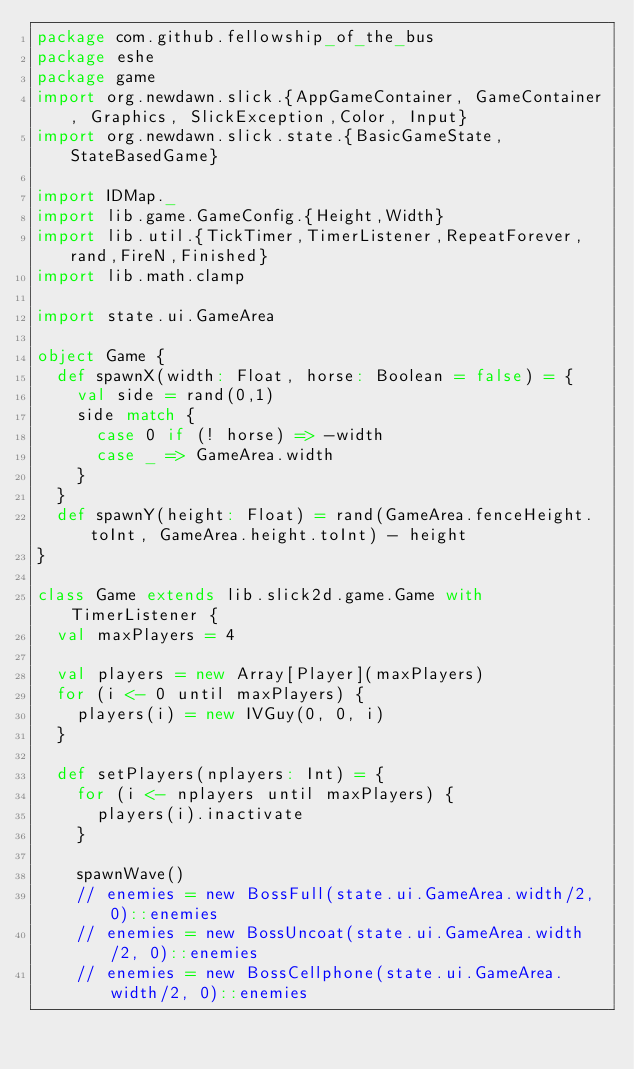<code> <loc_0><loc_0><loc_500><loc_500><_Scala_>package com.github.fellowship_of_the_bus
package eshe
package game
import org.newdawn.slick.{AppGameContainer, GameContainer, Graphics, SlickException,Color, Input}
import org.newdawn.slick.state.{BasicGameState, StateBasedGame}

import IDMap._
import lib.game.GameConfig.{Height,Width}
import lib.util.{TickTimer,TimerListener,RepeatForever,rand,FireN,Finished}
import lib.math.clamp

import state.ui.GameArea

object Game {
  def spawnX(width: Float, horse: Boolean = false) = {
    val side = rand(0,1)
    side match {
      case 0 if (! horse) => -width
      case _ => GameArea.width
    }
  }
  def spawnY(height: Float) = rand(GameArea.fenceHeight.toInt, GameArea.height.toInt) - height
}

class Game extends lib.slick2d.game.Game with TimerListener {
  val maxPlayers = 4

  val players = new Array[Player](maxPlayers)
  for (i <- 0 until maxPlayers) {
    players(i) = new IVGuy(0, 0, i)
  }

  def setPlayers(nplayers: Int) = {
    for (i <- nplayers until maxPlayers) {
      players(i).inactivate
    }

    spawnWave()
    // enemies = new BossFull(state.ui.GameArea.width/2, 0)::enemies
    // enemies = new BossUncoat(state.ui.GameArea.width/2, 0)::enemies
    // enemies = new BossCellphone(state.ui.GameArea.width/2, 0)::enemies</code> 